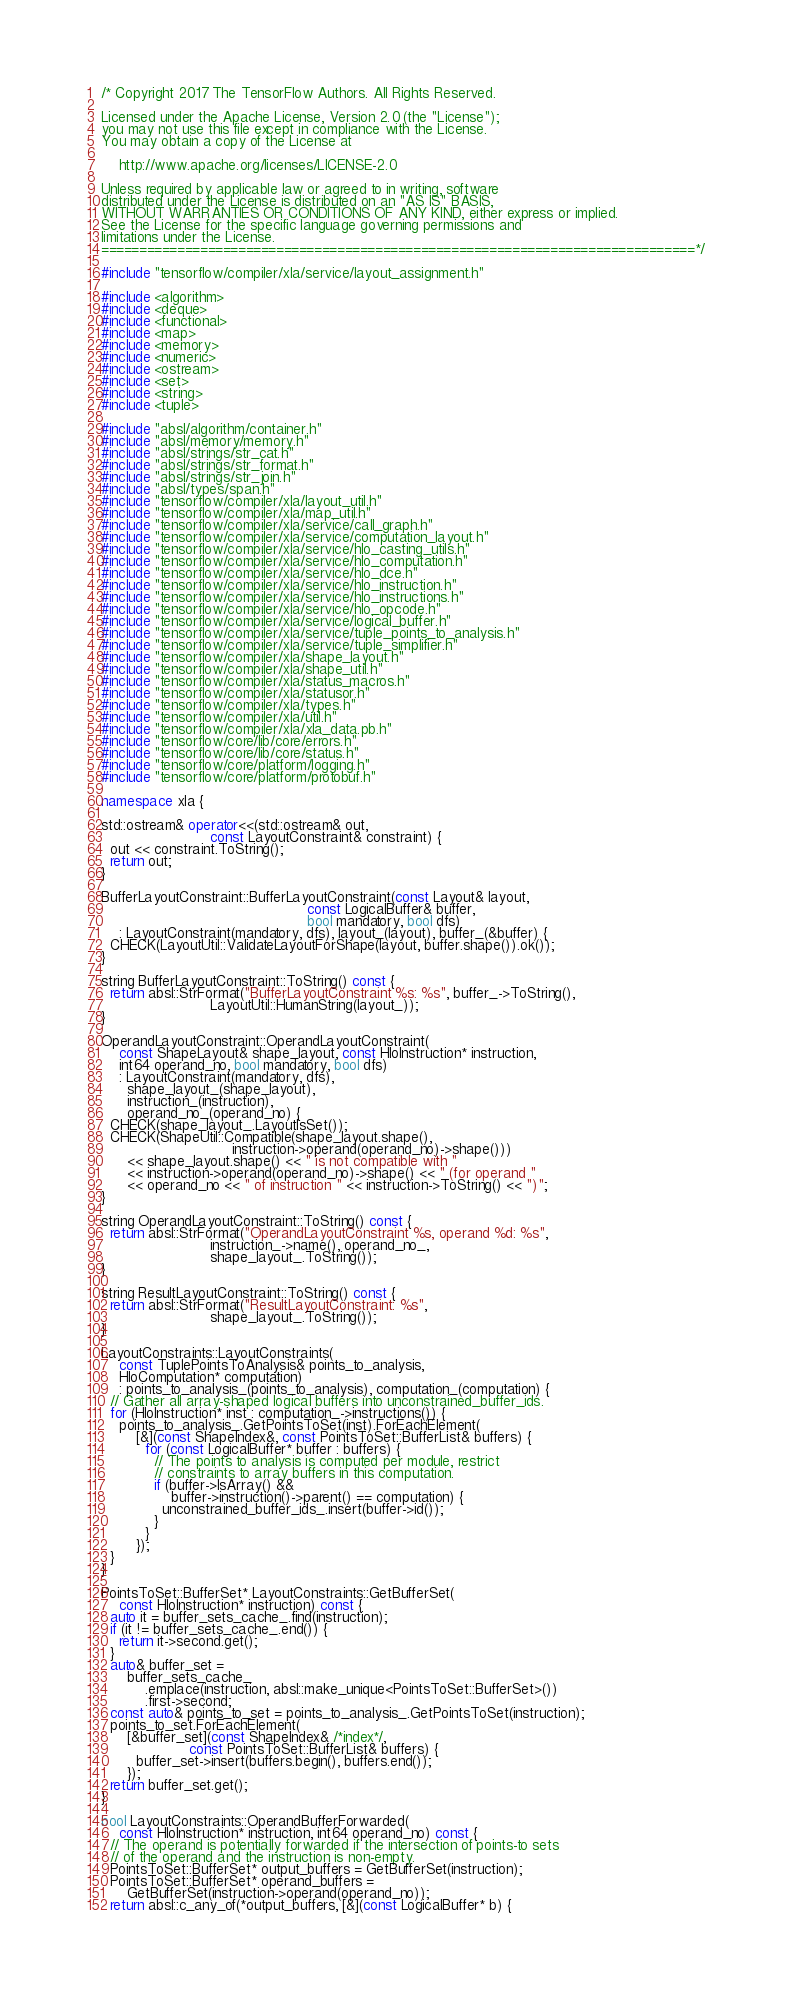Convert code to text. <code><loc_0><loc_0><loc_500><loc_500><_C++_>/* Copyright 2017 The TensorFlow Authors. All Rights Reserved.

Licensed under the Apache License, Version 2.0 (the "License");
you may not use this file except in compliance with the License.
You may obtain a copy of the License at

    http://www.apache.org/licenses/LICENSE-2.0

Unless required by applicable law or agreed to in writing, software
distributed under the License is distributed on an "AS IS" BASIS,
WITHOUT WARRANTIES OR CONDITIONS OF ANY KIND, either express or implied.
See the License for the specific language governing permissions and
limitations under the License.
==============================================================================*/

#include "tensorflow/compiler/xla/service/layout_assignment.h"

#include <algorithm>
#include <deque>
#include <functional>
#include <map>
#include <memory>
#include <numeric>
#include <ostream>
#include <set>
#include <string>
#include <tuple>

#include "absl/algorithm/container.h"
#include "absl/memory/memory.h"
#include "absl/strings/str_cat.h"
#include "absl/strings/str_format.h"
#include "absl/strings/str_join.h"
#include "absl/types/span.h"
#include "tensorflow/compiler/xla/layout_util.h"
#include "tensorflow/compiler/xla/map_util.h"
#include "tensorflow/compiler/xla/service/call_graph.h"
#include "tensorflow/compiler/xla/service/computation_layout.h"
#include "tensorflow/compiler/xla/service/hlo_casting_utils.h"
#include "tensorflow/compiler/xla/service/hlo_computation.h"
#include "tensorflow/compiler/xla/service/hlo_dce.h"
#include "tensorflow/compiler/xla/service/hlo_instruction.h"
#include "tensorflow/compiler/xla/service/hlo_instructions.h"
#include "tensorflow/compiler/xla/service/hlo_opcode.h"
#include "tensorflow/compiler/xla/service/logical_buffer.h"
#include "tensorflow/compiler/xla/service/tuple_points_to_analysis.h"
#include "tensorflow/compiler/xla/service/tuple_simplifier.h"
#include "tensorflow/compiler/xla/shape_layout.h"
#include "tensorflow/compiler/xla/shape_util.h"
#include "tensorflow/compiler/xla/status_macros.h"
#include "tensorflow/compiler/xla/statusor.h"
#include "tensorflow/compiler/xla/types.h"
#include "tensorflow/compiler/xla/util.h"
#include "tensorflow/compiler/xla/xla_data.pb.h"
#include "tensorflow/core/lib/core/errors.h"
#include "tensorflow/core/lib/core/status.h"
#include "tensorflow/core/platform/logging.h"
#include "tensorflow/core/platform/protobuf.h"

namespace xla {

std::ostream& operator<<(std::ostream& out,
                         const LayoutConstraint& constraint) {
  out << constraint.ToString();
  return out;
}

BufferLayoutConstraint::BufferLayoutConstraint(const Layout& layout,
                                               const LogicalBuffer& buffer,
                                               bool mandatory, bool dfs)
    : LayoutConstraint(mandatory, dfs), layout_(layout), buffer_(&buffer) {
  CHECK(LayoutUtil::ValidateLayoutForShape(layout, buffer.shape()).ok());
}

string BufferLayoutConstraint::ToString() const {
  return absl::StrFormat("BufferLayoutConstraint %s: %s", buffer_->ToString(),
                         LayoutUtil::HumanString(layout_));
}

OperandLayoutConstraint::OperandLayoutConstraint(
    const ShapeLayout& shape_layout, const HloInstruction* instruction,
    int64 operand_no, bool mandatory, bool dfs)
    : LayoutConstraint(mandatory, dfs),
      shape_layout_(shape_layout),
      instruction_(instruction),
      operand_no_(operand_no) {
  CHECK(shape_layout_.LayoutIsSet());
  CHECK(ShapeUtil::Compatible(shape_layout.shape(),
                              instruction->operand(operand_no)->shape()))
      << shape_layout.shape() << " is not compatible with "
      << instruction->operand(operand_no)->shape() << " (for operand "
      << operand_no << " of instruction " << instruction->ToString() << ")";
}

string OperandLayoutConstraint::ToString() const {
  return absl::StrFormat("OperandLayoutConstraint %s, operand %d: %s",
                         instruction_->name(), operand_no_,
                         shape_layout_.ToString());
}

string ResultLayoutConstraint::ToString() const {
  return absl::StrFormat("ResultLayoutConstraint: %s",
                         shape_layout_.ToString());
}

LayoutConstraints::LayoutConstraints(
    const TuplePointsToAnalysis& points_to_analysis,
    HloComputation* computation)
    : points_to_analysis_(points_to_analysis), computation_(computation) {
  // Gather all array-shaped logical buffers into unconstrained_buffer_ids.
  for (HloInstruction* inst : computation_->instructions()) {
    points_to_analysis_.GetPointsToSet(inst).ForEachElement(
        [&](const ShapeIndex&, const PointsToSet::BufferList& buffers) {
          for (const LogicalBuffer* buffer : buffers) {
            // The points to analysis is computed per module, restrict
            // constraints to array buffers in this computation.
            if (buffer->IsArray() &&
                buffer->instruction()->parent() == computation) {
              unconstrained_buffer_ids_.insert(buffer->id());
            }
          }
        });
  }
}

PointsToSet::BufferSet* LayoutConstraints::GetBufferSet(
    const HloInstruction* instruction) const {
  auto it = buffer_sets_cache_.find(instruction);
  if (it != buffer_sets_cache_.end()) {
    return it->second.get();
  }
  auto& buffer_set =
      buffer_sets_cache_
          .emplace(instruction, absl::make_unique<PointsToSet::BufferSet>())
          .first->second;
  const auto& points_to_set = points_to_analysis_.GetPointsToSet(instruction);
  points_to_set.ForEachElement(
      [&buffer_set](const ShapeIndex& /*index*/,
                    const PointsToSet::BufferList& buffers) {
        buffer_set->insert(buffers.begin(), buffers.end());
      });
  return buffer_set.get();
}

bool LayoutConstraints::OperandBufferForwarded(
    const HloInstruction* instruction, int64 operand_no) const {
  // The operand is potentially forwarded if the intersection of points-to sets
  // of the operand and the instruction is non-empty.
  PointsToSet::BufferSet* output_buffers = GetBufferSet(instruction);
  PointsToSet::BufferSet* operand_buffers =
      GetBufferSet(instruction->operand(operand_no));
  return absl::c_any_of(*output_buffers, [&](const LogicalBuffer* b) {</code> 